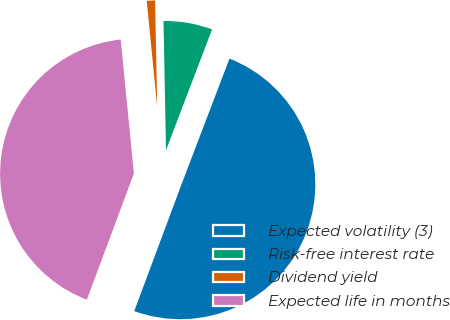Convert chart to OTSL. <chart><loc_0><loc_0><loc_500><loc_500><pie_chart><fcel>Expected volatility (3)<fcel>Risk-free interest rate<fcel>Dividend yield<fcel>Expected life in months<nl><fcel>49.88%<fcel>6.11%<fcel>1.25%<fcel>42.75%<nl></chart> 